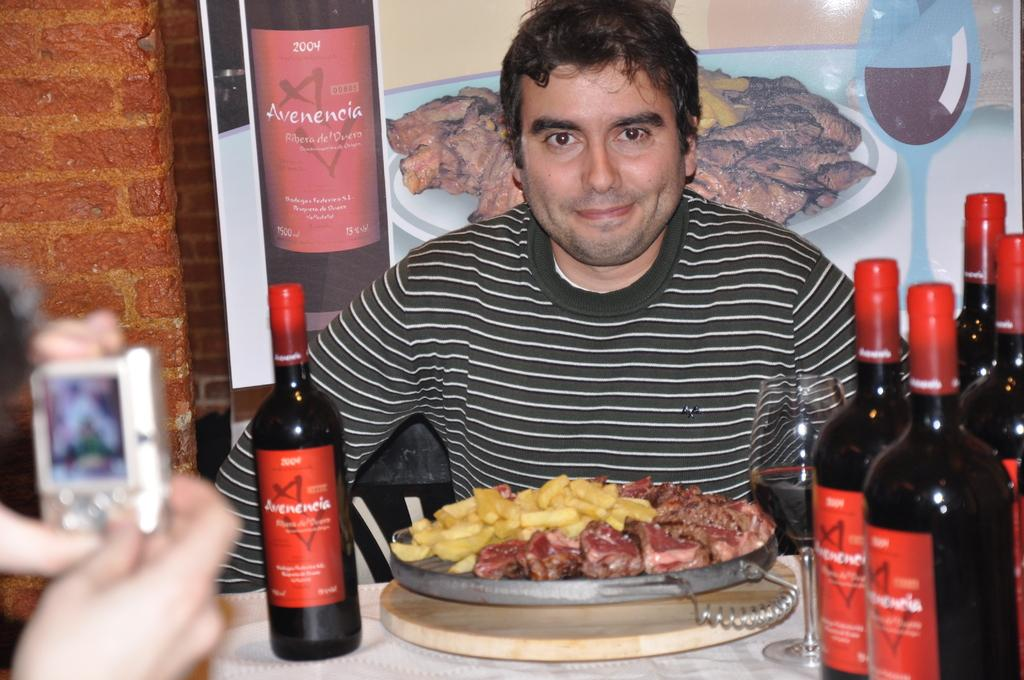Provide a one-sentence caption for the provided image. Bottles of alcohol read Avenencia on their red labels. 